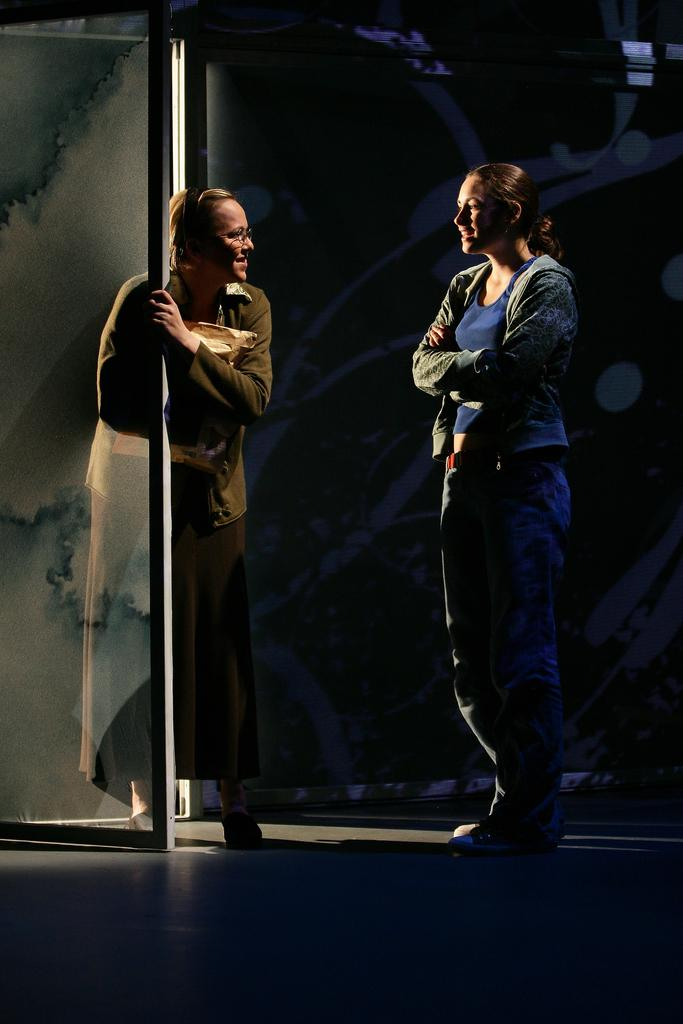How many people are in the image? There are two persons in the image. What are the persons doing in the image? The persons are standing. What are the persons wearing in the image? The persons are wearing clothes. What can be seen on the left side of the image? There is a glass door on the left side of the image. What type of debt is being discussed by the persons in the image? There is no mention of debt in the image, as the conversation between the persons is not depicted. How are the persons rubbing the glass door in the image? The persons are not rubbing the glass door in the image; they are simply standing near it. 